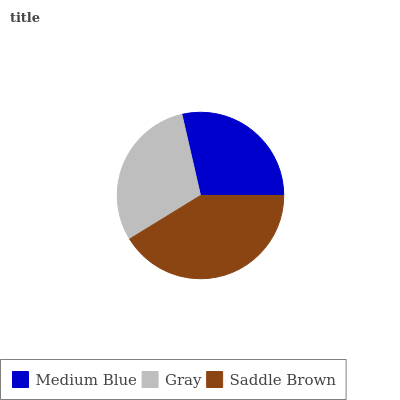Is Medium Blue the minimum?
Answer yes or no. Yes. Is Saddle Brown the maximum?
Answer yes or no. Yes. Is Gray the minimum?
Answer yes or no. No. Is Gray the maximum?
Answer yes or no. No. Is Gray greater than Medium Blue?
Answer yes or no. Yes. Is Medium Blue less than Gray?
Answer yes or no. Yes. Is Medium Blue greater than Gray?
Answer yes or no. No. Is Gray less than Medium Blue?
Answer yes or no. No. Is Gray the high median?
Answer yes or no. Yes. Is Gray the low median?
Answer yes or no. Yes. Is Saddle Brown the high median?
Answer yes or no. No. Is Medium Blue the low median?
Answer yes or no. No. 